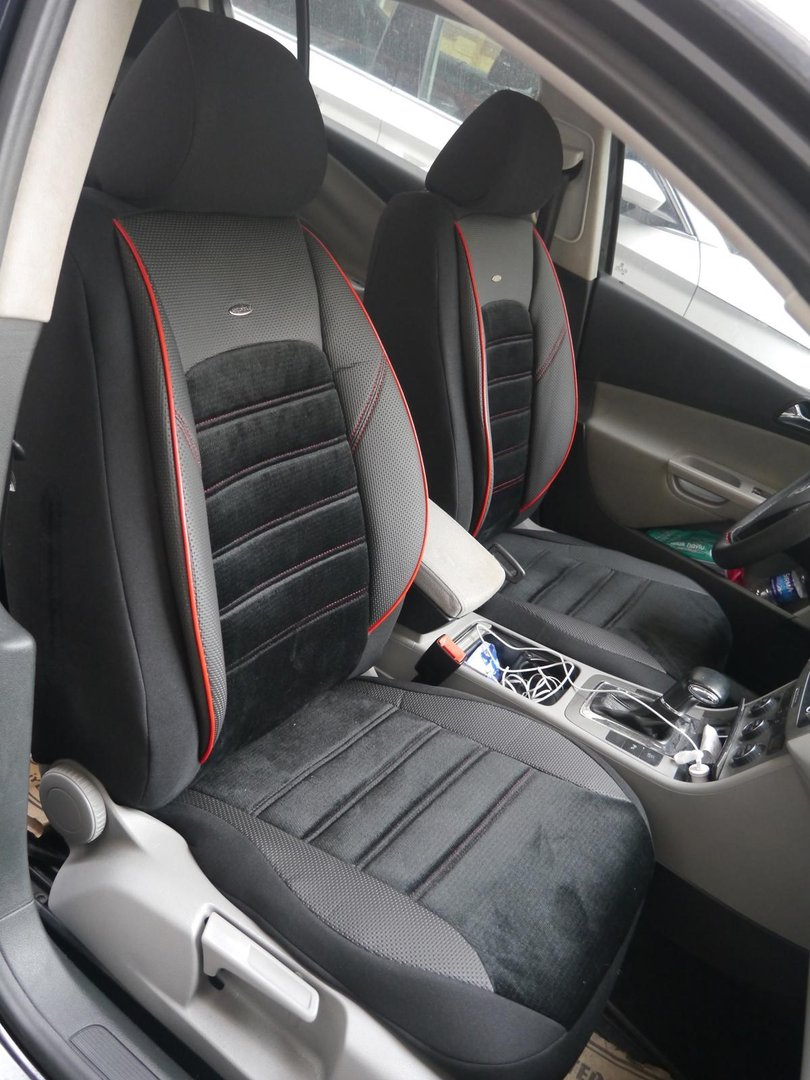What might be the car owner’s occupation and hobbies based on the car’s cleanliness and items present? The clean and organized interior of the car, coupled with the presence of a charging cable and a possibly functional item like a water bottle or cleaning product, suggests that the owner could be in a profession that values efficiency and preparedness, such as an office worker, a sales representative, or someone in the tech industry. Their hobbies could involve tech and gadgets, given the charging cable, and they might also enjoy fitness or outdoor activities, inferred from the presence of the water bottle. Overall, the car’s condition and items present suggest someone who balances a professional, resourceful lifestyle with health and wellness.  Can you see any indicators of personal style or aesthetic preferences in the car interior? The car interior features sleek, modern design elements, with a neat and uncluttered appearance, suggesting the car owner has a preference for simplicity and order. The black and red cushioned seats give a hint of a sporty, yet sophisticated style, indicating an appreciation for both comfort and visual appeal. The integrated compartments and organized layout suggest that the owner values functionality and efficient use of space, further reflecting their practical and modern aesthetic.  Describe how the car owner might keep their car maintained and what this says about their character. The meticulous condition of the car interior implies that the owner likely adheres to a regular maintenance routine, which might include weekly cleaning sessions and periodic checks for any issues. They may use the cleaning product stored in the car to quickly address any dirt or spills, ensuring the car remains pristine. This attentiveness to maintenance reflects a character that values responsibility, organization, and perhaps a sense of pride in their possessions. It indicates someone who is diligent, detail-oriented, and considerate of their environment, making efforts to preserve the quality and appearance of their vehicle.  If the car could tell a story about its owner, what would it reveal? If this car could narrate its owner’s story, it would tell of a person who is constantly on the go, managing a busy schedule that requires both efficiency and adaptability. The car would speak of trips to various destinations, both near and far, with the owner always prepared thanks to the readily available charging cable and versatile blue-capped item. It would reveal a tidy, considerate person who maintains their surroundings carefully, indicating a layered personality that balances practicality with a touch of style, shown by the sleek, sporty seat design. The car could recount countless moments of the owner engaging in thoughtful gestures, such as ensuring their devices are charged and the interiors clean, which highlights their proactive and considerate nature. 